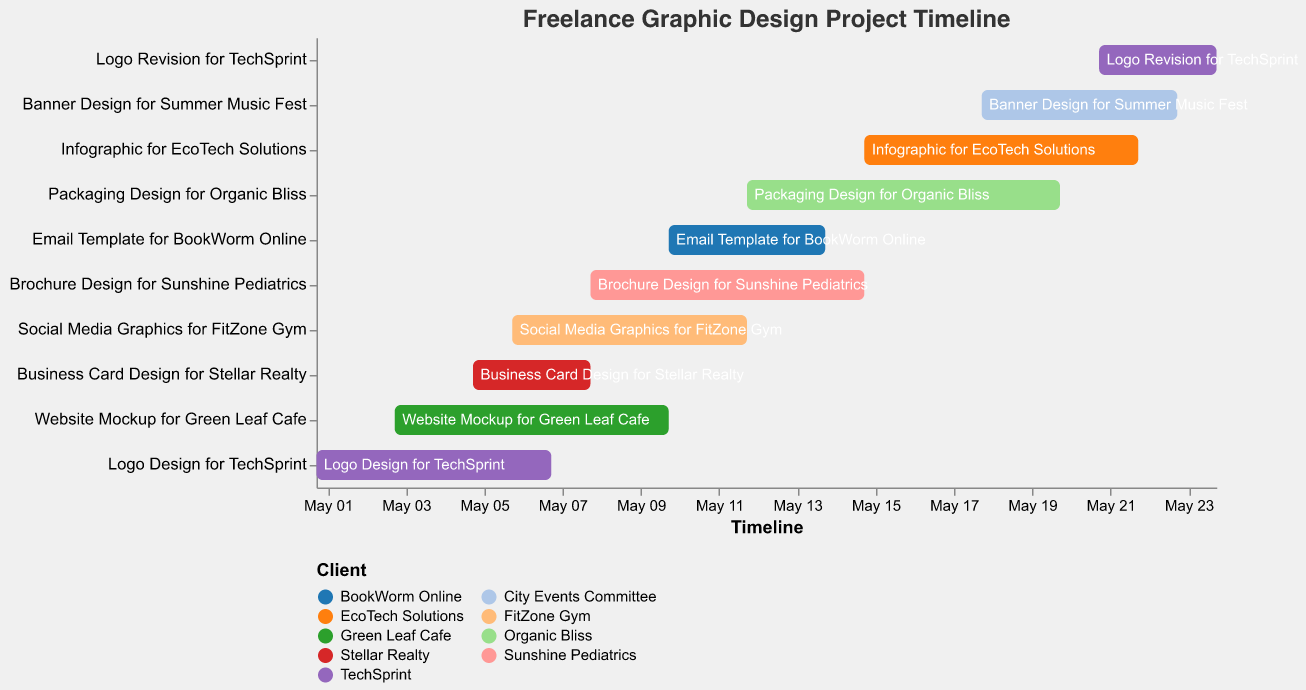What is the title of the Gantt chart? The title of the chart is displayed at the top and reads "Freelance Graphic Design Project Timeline"
Answer: Freelance Graphic Design Project Timeline How many projects are depicted in the Gantt chart? To find the number of projects, count the number of bars (tasks) listed on the vertical axis.
Answer: 10 Which client has the most tasks? Look at the color legend to identify clients, then count the frequency of each color. "TechSprint" appears twice, which is more than any other client.
Answer: TechSprint When does the "Social Media Graphics for FitZone Gym" task start and end? Locate "Social Media Graphics for FitZone Gym" on the y-axis and check its corresponding start and end dates on the x-axis.
Answer: May 6 - May 12 Which two tasks overlap between May 8 and May 10? Find tasks that start before May 10 and end on or after May 8. "Brochure Design for Sunshine Pediatrics" and "Email Template for BookWorm Online" meet this condition.
Answer: Brochure Design for Sunshine Pediatrics and Email Template for BookWorm Online Is the "Logo Revision for TechSprint" completed before or after the "Banner Design for Summer Music Fest"? Locate both tasks on the timeline and compare their end dates. "Logo Revision for TechSprint" ends on May 24, while "Banner Design for Summer Music Fest" ends on May 23.
Answer: After Which task spans the longest period, and how many days does it cover? Calculate the duration for each task by subtracting the start date from the end date. "Packaging Design for Organic Bliss" spans from May 12 to May 20, covering 8 days.
Answer: Packaging Design for Organic Bliss, 8 days How many tasks are scheduled to start in the second week of May (May 8 - May 14)? Identify tasks with start dates between May 8 and May 14 by checking the x-axis for the start dates. Four tasks ("Brochure Design for Sunshine Pediatrics", "Email Template for BookWorm Online", "Packaging Design for Organic Bliss", "Infographic for EcoTech Solutions") start in this period.
Answer: 4 Which project is scheduled to end last? Find the task with the latest end date by inspecting the rightmost bar on the timeline. "Logo Revision for TechSprint" ends on May 24.
Answer: Logo Revision for TechSprint 